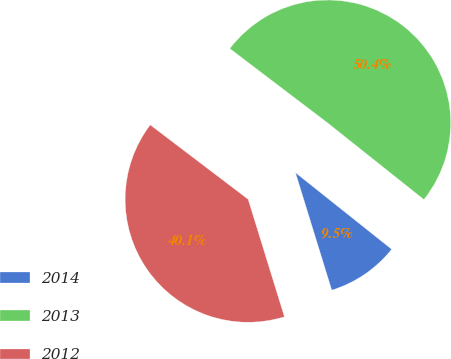Convert chart to OTSL. <chart><loc_0><loc_0><loc_500><loc_500><pie_chart><fcel>2014<fcel>2013<fcel>2012<nl><fcel>9.53%<fcel>50.36%<fcel>40.11%<nl></chart> 